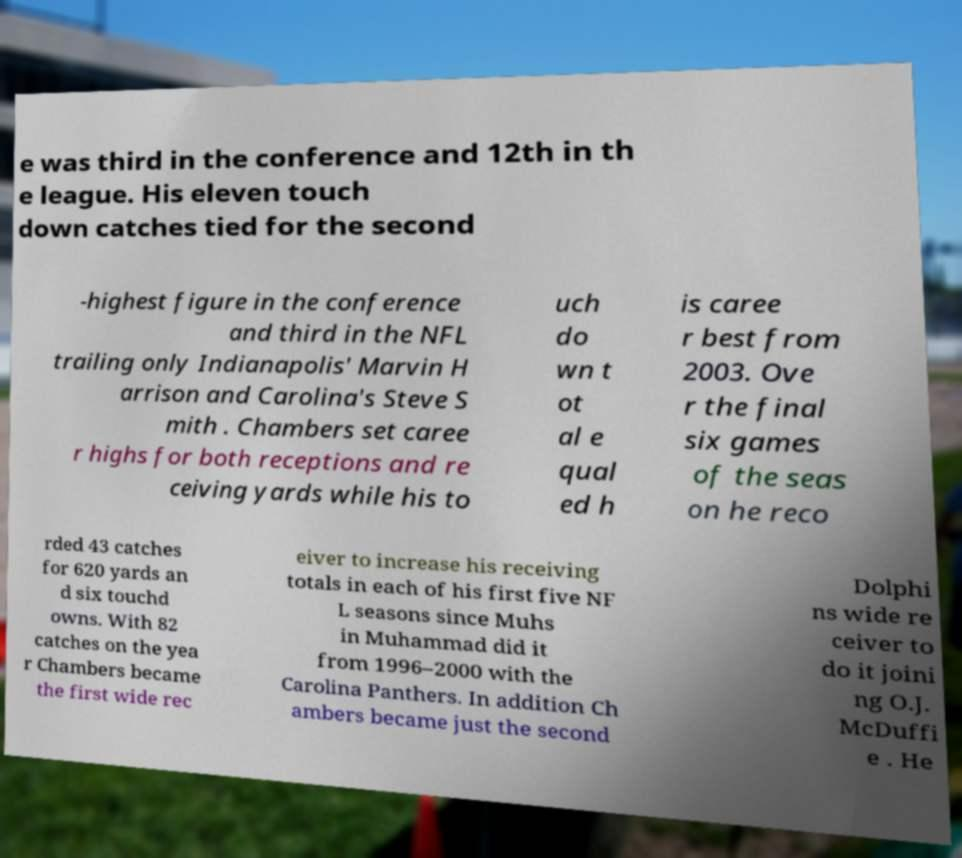There's text embedded in this image that I need extracted. Can you transcribe it verbatim? e was third in the conference and 12th in th e league. His eleven touch down catches tied for the second -highest figure in the conference and third in the NFL trailing only Indianapolis' Marvin H arrison and Carolina's Steve S mith . Chambers set caree r highs for both receptions and re ceiving yards while his to uch do wn t ot al e qual ed h is caree r best from 2003. Ove r the final six games of the seas on he reco rded 43 catches for 620 yards an d six touchd owns. With 82 catches on the yea r Chambers became the first wide rec eiver to increase his receiving totals in each of his first five NF L seasons since Muhs in Muhammad did it from 1996–2000 with the Carolina Panthers. In addition Ch ambers became just the second Dolphi ns wide re ceiver to do it joini ng O.J. McDuffi e . He 